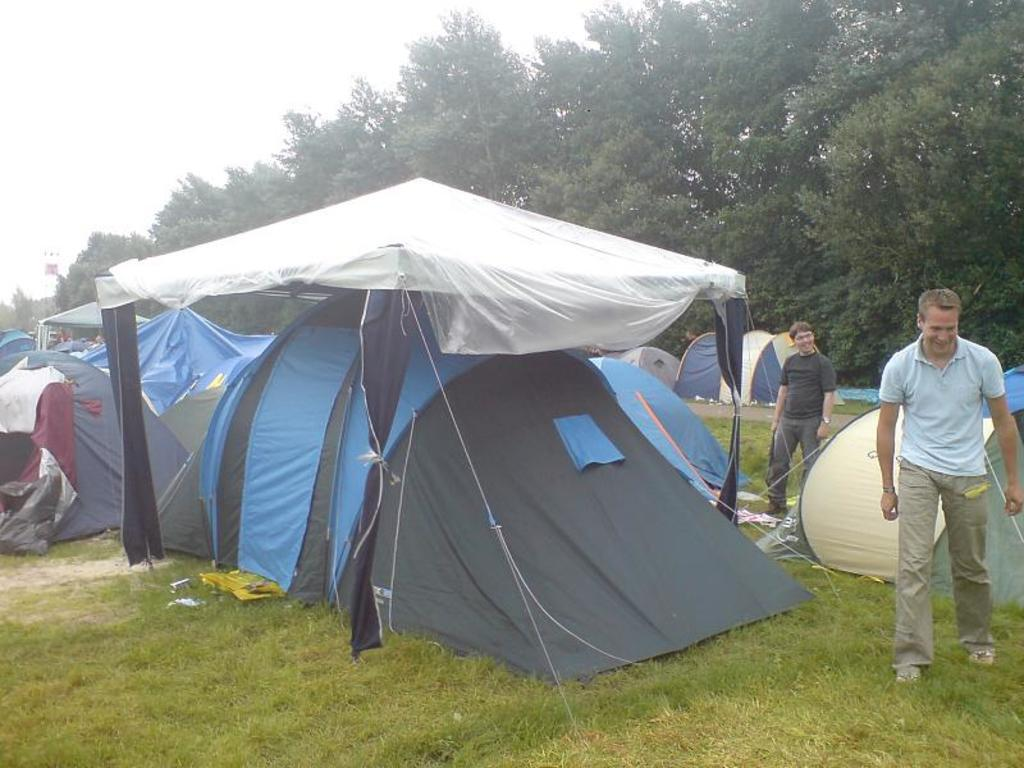What type of structures are visible in the image? There are tents in the image. Who or what can be seen in the image besides the tents? There are people in the image. What type of ground surface is visible at the bottom of the image? There is grass at the bottom of the image. What can be seen in the background of the image? There are trees and the sky visible in the background of the image. How many ladybugs are crawling on the quill in the image? There are no ladybugs or quills present in the image. 